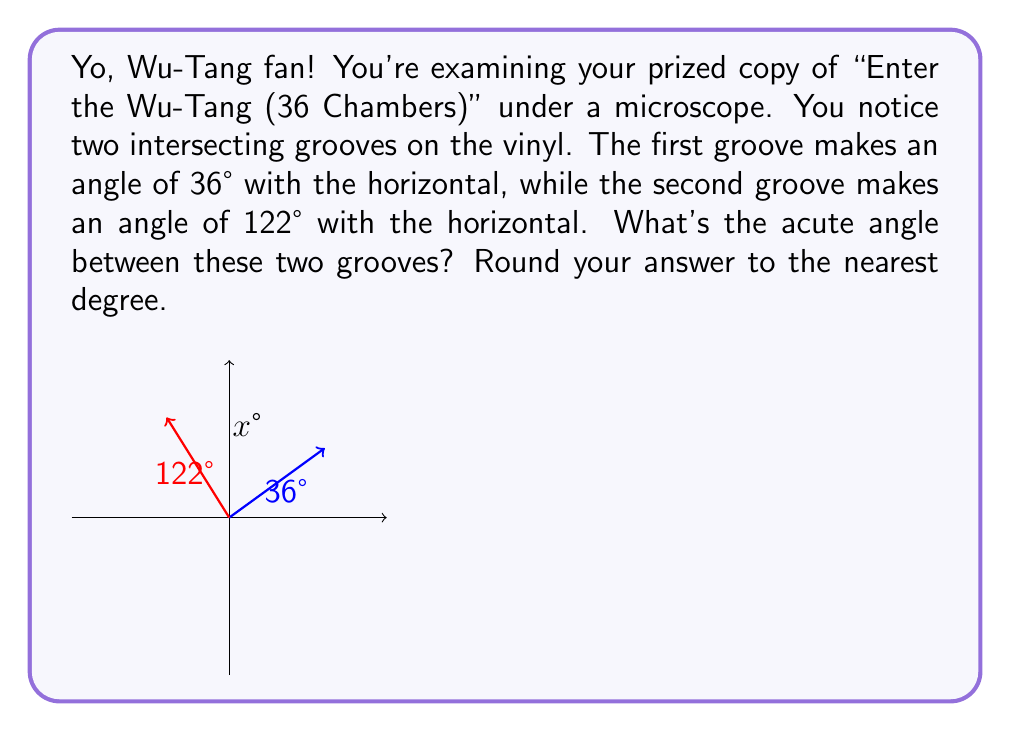Can you answer this question? Alright, let's break this down like a Wu-Tang verse:

1) First, we need to understand that the angle between two lines is the absolute difference between their angles with respect to a common reference line. In this case, our reference is the horizontal line.

2) We're given:
   - Groove 1 makes an angle of 36° with the horizontal
   - Groove 2 makes an angle of 122° with the horizontal

3) To find the angle between these grooves, we subtract the smaller angle from the larger angle:

   $$ |122° - 36°| = 86° $$

4) However, we're asked for the acute angle. In geometry, there are always two angles between intersecting lines: an acute angle (less than 90°) and an obtuse angle (greater than 90°). These angles are supplementary, meaning they add up to 180°.

5) If the angle we calculated (86°) is acute, that's our answer. If it's obtuse, we need to subtract it from 180° to get the acute angle:

   $$ 180° - 86° = 94° $$

6) Since 86° is already acute, we don't need to perform this last step.

7) The question asks to round to the nearest degree, but 86° is already a whole number, so no rounding is necessary.

Therefore, the acute angle between the two grooves is 86°.
Answer: 86° 